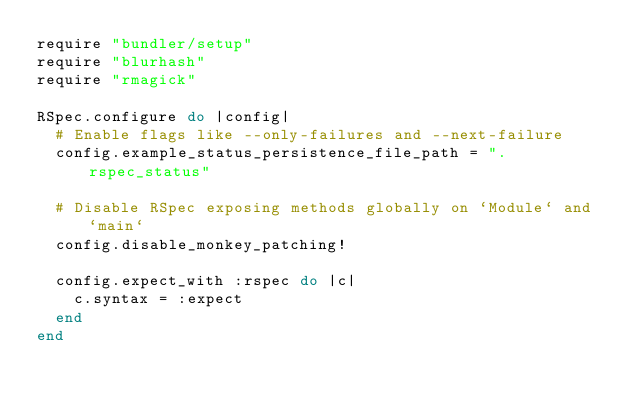<code> <loc_0><loc_0><loc_500><loc_500><_Ruby_>require "bundler/setup"
require "blurhash"
require "rmagick"

RSpec.configure do |config|
  # Enable flags like --only-failures and --next-failure
  config.example_status_persistence_file_path = ".rspec_status"

  # Disable RSpec exposing methods globally on `Module` and `main`
  config.disable_monkey_patching!

  config.expect_with :rspec do |c|
    c.syntax = :expect
  end
end
</code> 